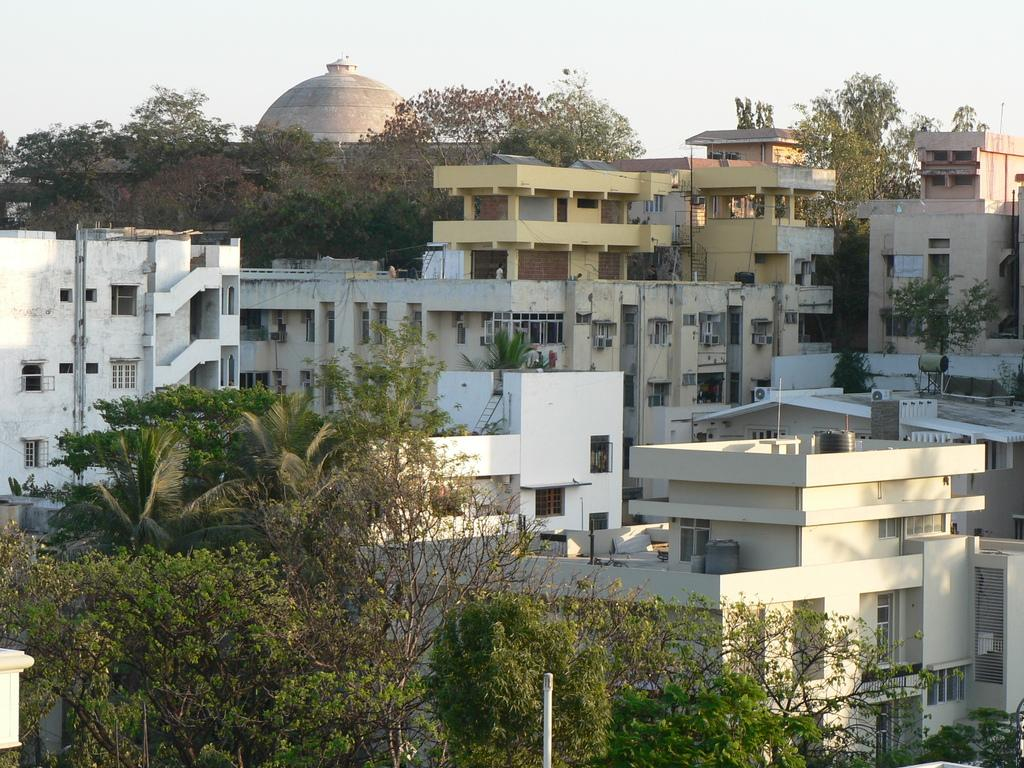What type of natural elements can be seen in the image? There are trees in the image. What man-made structures are visible in the image? There are poles and buildings in the image. What is visible at the top of the image? The sky is visible at the top of the image. What type of plate is being used to hold the circle in the image? There is no plate or circle present in the image. How many hot items can be seen in the image? There are no hot items visible in the image. 